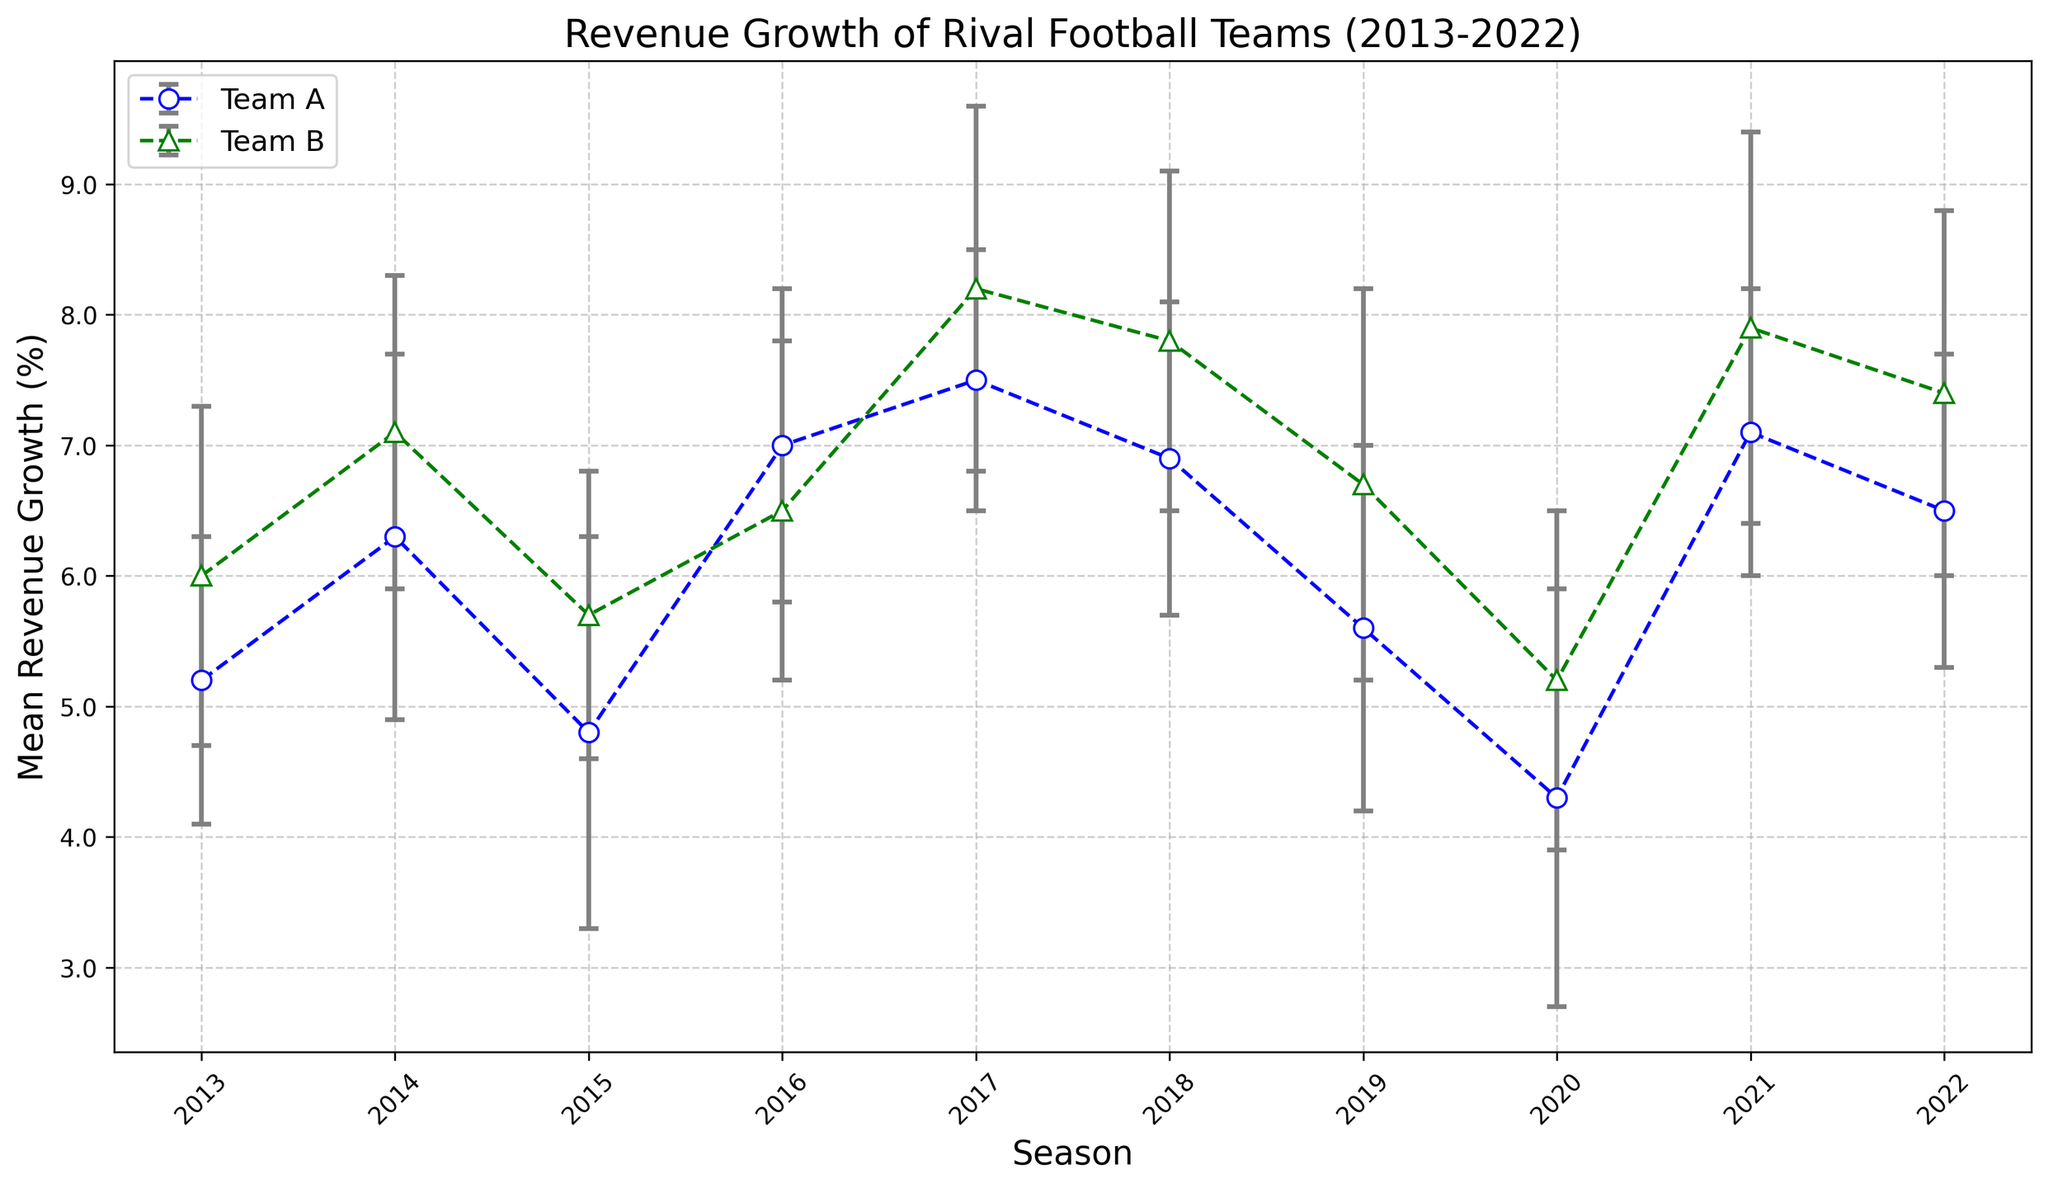What's the mean revenue growth of Team A in 2018? To find the mean revenue growth of Team A in 2018, locate the data point for Team A for the year 2018 on the plot. The figure shows Team A with a mean revenue growth of 6.9% in 2018.
Answer: 6.9% Which team had a higher mean revenue growth in 2017? Compare the mean revenue growth values of both teams for the year 2017. Team A had a mean revenue growth of 7.5%, while Team B had 8.2%. Therefore, Team B had a higher mean revenue growth in 2017.
Answer: Team B In which season did Team A have its lowest mean revenue growth? To identify the season with the lowest mean revenue growth for Team A, examine all data points for Team A across the years. The lowest mean revenue growth for Team A occurred in 2020, with a value of 4.3%.
Answer: 2020 What is the difference in mean revenue growth between Team A and Team B in 2015? Calculate the difference in mean revenue growth between Team A and Team B for the year 2015. Team A's mean revenue growth is 4.8%, and Team B's is 5.7%. The difference is 5.7% - 4.8% = 0.9%.
Answer: 0.9% Did Team B's revenue growth ever decline compared to the previous year? Examine the revenue growth values for consecutive years for Team B. From 2013 to 2022, there is no instance where the revenue growth of Team B declined compared to the previous year.
Answer: No Which team showed more variation in revenue growth over the years? To determine which team had more variation, compare the error bars (standard deviation) for each team across all seasons. Team B generally has slightly larger error bars than Team A, indicating more variation.
Answer: Team B What was the average mean revenue growth of Team B from 2013 to 2022? Calculate the average of Team B's mean revenue growth over the years: (6.0 + 7.1 + 5.7 + 6.5 + 8.2 + 7.8 + 6.7 + 5.2 + 7.9 + 7.4) / 10. The sum is 68.5%, so the average is 68.5 / 10 = 6.85%.
Answer: 6.85% Which season had the smallest difference in mean revenue growth between the two teams? Calculate the difference in mean revenue growth between the two teams for each season. The smallest difference is found in 2016, where Team A has 7.0% and Team B has 6.5%; the difference is 0.5%.
Answer: 2016 When did both teams either achieve or exceed a mean revenue growth of 7%? Locate the seasons where both Team A and Team B have mean revenue growth values of at least 7%. In 2017, Team A had 7.5% and Team B had 8.2%. Also, in 2021, Team A had 7.1% and Team B had 7.9%.
Answer: 2017, 2021 